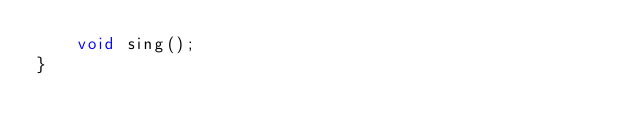<code> <loc_0><loc_0><loc_500><loc_500><_Java_>    void sing();
}
</code> 